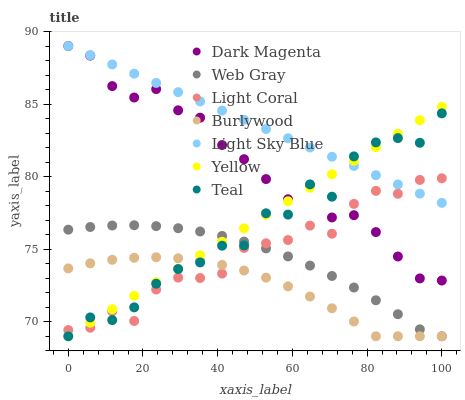Does Burlywood have the minimum area under the curve?
Answer yes or no. Yes. Does Light Sky Blue have the maximum area under the curve?
Answer yes or no. Yes. Does Dark Magenta have the minimum area under the curve?
Answer yes or no. No. Does Dark Magenta have the maximum area under the curve?
Answer yes or no. No. Is Yellow the smoothest?
Answer yes or no. Yes. Is Teal the roughest?
Answer yes or no. Yes. Is Dark Magenta the smoothest?
Answer yes or no. No. Is Dark Magenta the roughest?
Answer yes or no. No. Does Web Gray have the lowest value?
Answer yes or no. Yes. Does Dark Magenta have the lowest value?
Answer yes or no. No. Does Light Sky Blue have the highest value?
Answer yes or no. Yes. Does Burlywood have the highest value?
Answer yes or no. No. Is Web Gray less than Light Sky Blue?
Answer yes or no. Yes. Is Dark Magenta greater than Burlywood?
Answer yes or no. Yes. Does Yellow intersect Light Coral?
Answer yes or no. Yes. Is Yellow less than Light Coral?
Answer yes or no. No. Is Yellow greater than Light Coral?
Answer yes or no. No. Does Web Gray intersect Light Sky Blue?
Answer yes or no. No. 